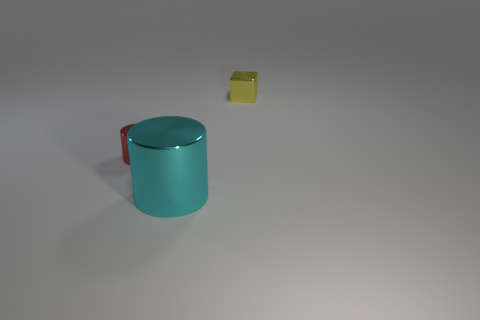There is a shiny thing in front of the metal cylinder to the left of the big cyan shiny cylinder; is there a shiny cylinder behind it?
Your answer should be very brief. Yes. What is the size of the cyan metal cylinder?
Give a very brief answer. Large. There is a thing that is in front of the tiny red metal cylinder; how big is it?
Provide a short and direct response. Large. There is a object that is in front of the red object; is its size the same as the block?
Give a very brief answer. No. What is the shape of the small red metallic object?
Ensure brevity in your answer.  Cylinder. What number of objects are both on the left side of the tiny yellow thing and on the right side of the tiny red object?
Make the answer very short. 1. Are there any other things that are made of the same material as the yellow block?
Ensure brevity in your answer.  Yes. Are there the same number of cyan metal things that are in front of the large cylinder and red shiny cylinders that are in front of the small cylinder?
Provide a short and direct response. Yes. Is the tiny cylinder made of the same material as the yellow object?
Your answer should be compact. Yes. What number of red things are either tiny cylinders or metallic cubes?
Your answer should be compact. 1. 